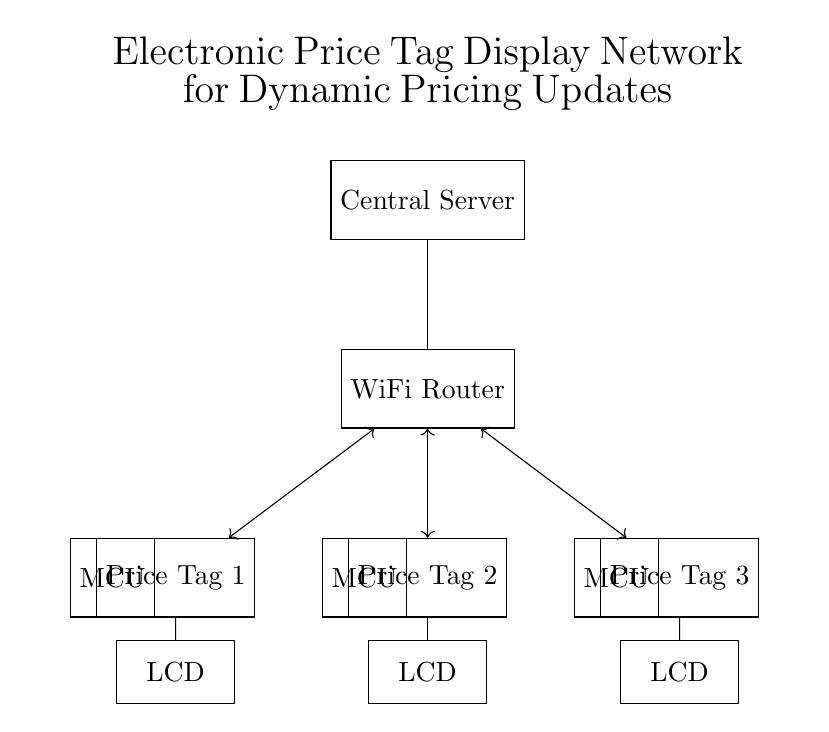What is the main component responsible for communication in this circuit? The WiFi Router acts as the main component that facilitates wireless communication between the central server and the electronic price tags.
Answer: WiFi Router How many electronic price tags are there in the circuit? There are three distinct electronic price tags shown in the circuit diagram, labeled as Price Tag 1, Price Tag 2, and Price Tag 3.
Answer: Three What type of displays are used for the price tags? LCD (Liquid Crystal Display) is used for displaying the price information on each price tag, indicated in the circuit by the labeled components connected to the tags.
Answer: LCD What is the function of the microcontrollers shown in the circuit? The microcontrollers (MCUs) manage the operation of each price tag, processing incoming data and controlling the LCD displays based on updates from the central server via the WiFi Router.
Answer: Manage operations How do the price tags receive updates? The updates are received wirelessly through the WiFi Router, which connects to all three price tags, allowing for dynamic updating of pricing information in real-time.
Answer: Wirelessly What type of network is this setup exemplifying? This setup exemplifies a wireless communication network designed specifically for dynamic pricing updates in a retail environment, connecting multiple devices seamlessly through WiFi.
Answer: Wireless network 